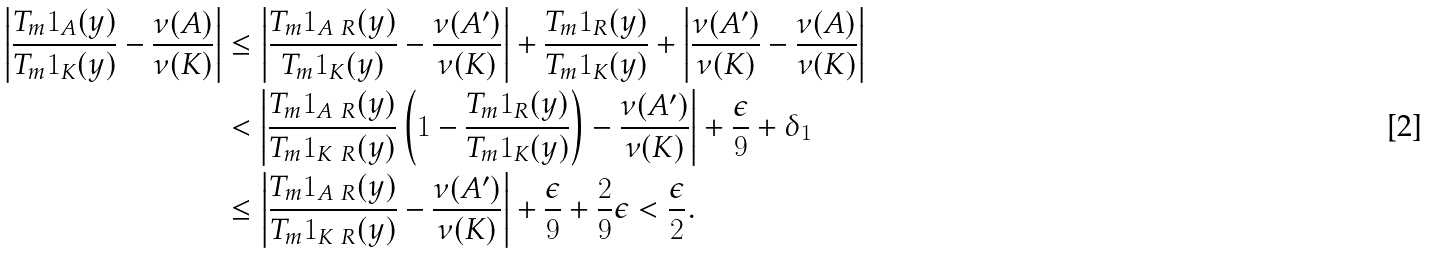Convert formula to latex. <formula><loc_0><loc_0><loc_500><loc_500>\left | \frac { T _ { m } { \mathbf 1 } _ { A } ( y ) } { T _ { m } { \mathbf 1 } _ { K } ( y ) } - \frac { \nu ( A ) } { \nu ( K ) } \right | & \leq \left | \frac { T _ { m } { \mathbf 1 } _ { A \ R } ( y ) } { T _ { m } { \mathbf 1 } _ { K } ( y ) } - \frac { \nu ( A ^ { \prime } ) } { \nu ( K ) } \right | + \frac { T _ { m } { \mathbf 1 } _ { R } ( y ) } { T _ { m } { \mathbf 1 } _ { K } ( y ) } + \left | \frac { \nu ( A ^ { \prime } ) } { \nu ( K ) } - \frac { \nu ( A ) } { \nu ( K ) } \right | \\ & < \left | \frac { T _ { m } { \mathbf 1 } _ { A \ R } ( y ) } { T _ { m } { \mathbf 1 } _ { K \ R } ( y ) } \left ( 1 - \frac { T _ { m } { \mathbf 1 } _ { R } ( y ) } { T _ { m } { \mathbf 1 } _ { K } ( y ) } \right ) - \frac { \nu ( A ^ { \prime } ) } { \nu ( K ) } \right | + \frac { \epsilon } { 9 } + \delta _ { 1 } \\ & \leq \left | \frac { T _ { m } { \mathbf 1 } _ { A \ R } ( y ) } { T _ { m } { \mathbf 1 } _ { K \ R } ( y ) } - \frac { \nu ( A ^ { \prime } ) } { \nu ( K ) } \right | + \frac { \epsilon } { 9 } + \frac { 2 } { 9 } \epsilon < \frac { \epsilon } { 2 } .</formula> 